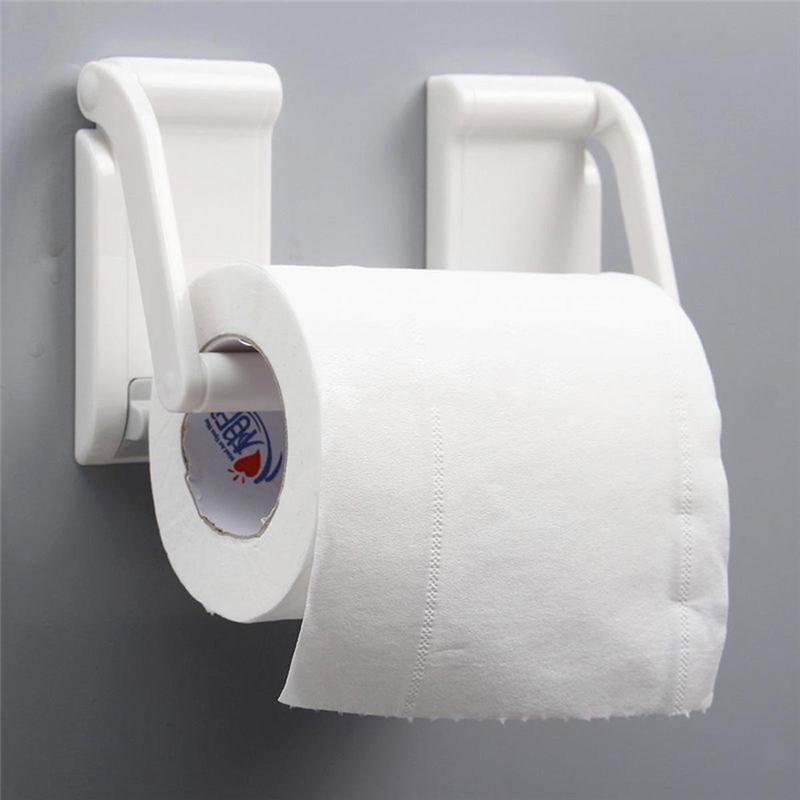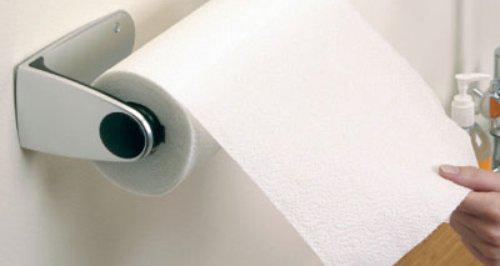The first image is the image on the left, the second image is the image on the right. For the images shown, is this caption "Each roll of toilet paper is hanging on a dispenser." true? Answer yes or no. Yes. The first image is the image on the left, the second image is the image on the right. For the images displayed, is the sentence "Each image shows a white paper roll hung on a dispenser." factually correct? Answer yes or no. Yes. 